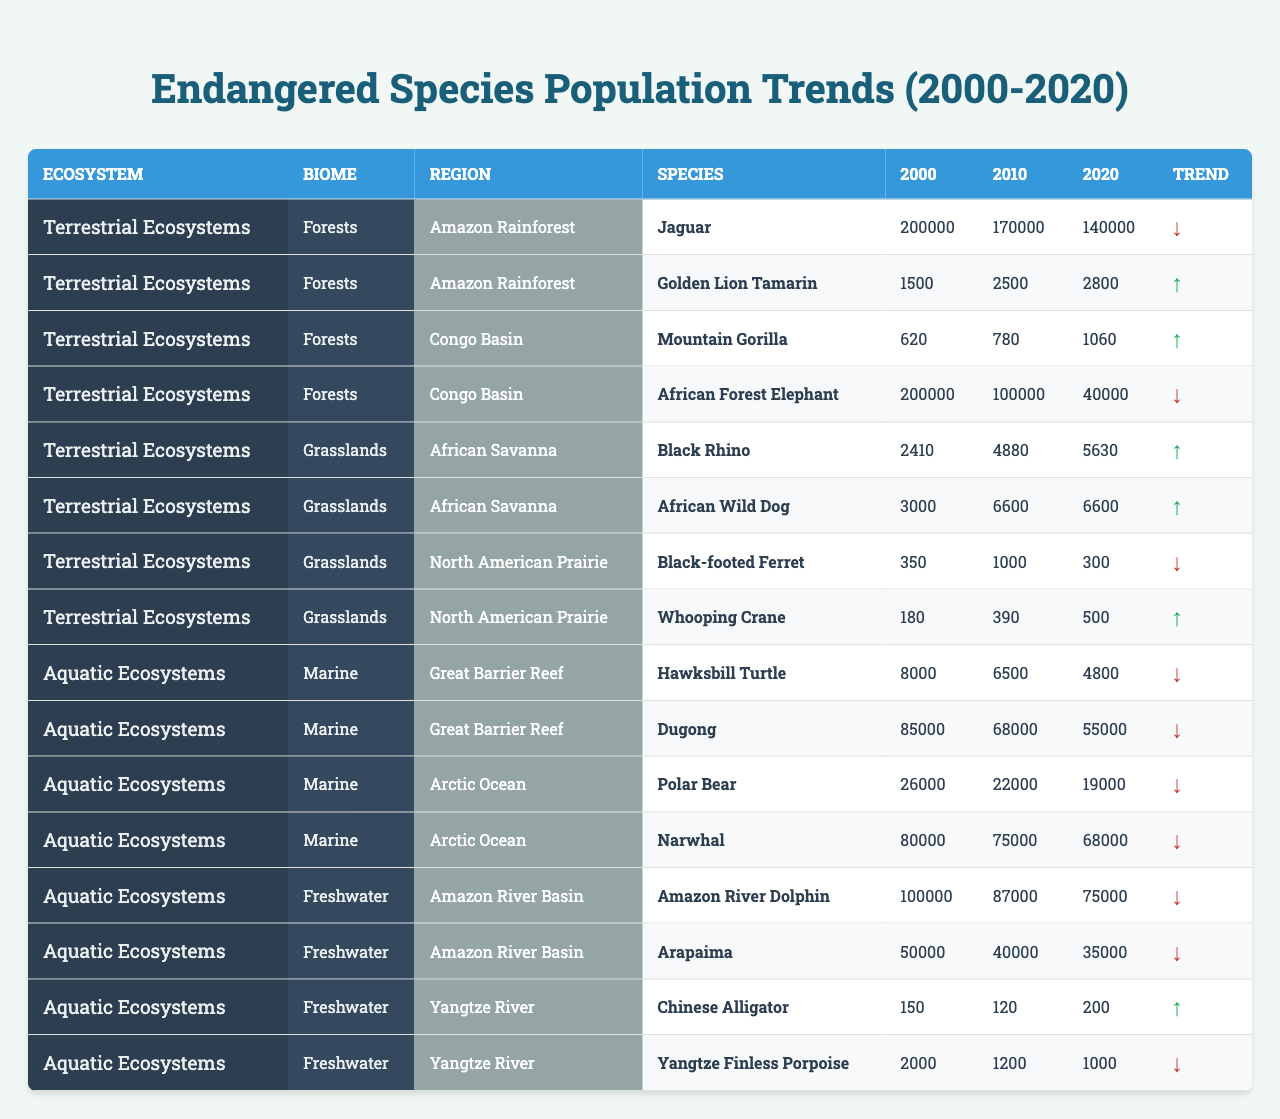What was the population of the Jaguar in 2020? The table shows that the population of the Jaguar in 2020 is listed under the Amazon Rainforest in the Terrestrial Ecosystems section, which states it is 140,000.
Answer: 140,000 Which species showed an increase in population between 2000 and 2020 in the African Savanna? Looking at the population data for the African Savanna, both the Black Rhino and African Wild Dog showed population increases from 2000 to 2020: Black Rhino from 2410 to 5630 and African Wild Dog from 3000 to 6600.
Answer: Black Rhino and African Wild Dog What is the population trend of the Hawksbill Turtle according to the table? The table indicates that the population of the Hawksbill Turtle decreased from 8000 in 2000 to 4800 in 2020. This represents a downward trend.
Answer: Decreasing How many species have a population over 100,000 in the year 2000? By analyzing the table, we can see that in 2000, the populations over 100,000 are: the Amazon River Dolphin (100,000) and the African Forest Elephant (200,000). Thus, there are two species.
Answer: 2 Which species has the lowest population in 2010 and what is that population? The 2010 populations for the species listed show that the Chinese Alligator had the lowest population, with only 120 individuals recorded.
Answer: Chinese Alligator, 120 What is the total population of endangered species in the Amazon River Basin for the year 2020? To calculate the total population in the Amazon River Basin for 2020, we sum the populations of the Amazon River Dolphin (75,000) and the Arapaima (35,000), yielding a total of 110,000.
Answer: 110,000 Is the population of the African Forest Elephant in 2020 greater or less than the population of the Mountain Gorilla? The population of the African Forest Elephant is 40,000 in 2020, while the Mountain Gorilla's population is 1,060. Since 40,000 is greater than 1,060, the answer is yes.
Answer: Greater In which ecosystem did the Golden Lion Tamarin show a population increase, and what was the increase from 2000 to 2020? The Golden Lion Tamarin is located in the Amazon Rainforest, which is part of the Terrestrial Ecosystems. Its population increased from 1,500 in 2000 to 2,800 in 2020, showing an increase of 1,300.
Answer: Amazon Rainforest, 1,300 If we sum the populations of the Amazon River Dolphin and the Dugong for the year 2020, what is the total? The total is obtained by adding the population of the Amazon River Dolphin (75,000) and the Dugong (55,000) for 2020, which equals 130,000.
Answer: 130,000 Which species in the Arctic Ocean experienced the most significant decrease in population from 2000 to 2020? Comparing the populations, the Polar Bear shows a decrease from 26,000 in 2000 to 19,000 in 2020, which is a decrease of 7,000. The Narwhal also decreased from 80,000 to 68,000, but the Polar Bear had the most significant decrease.
Answer: Polar Bear 